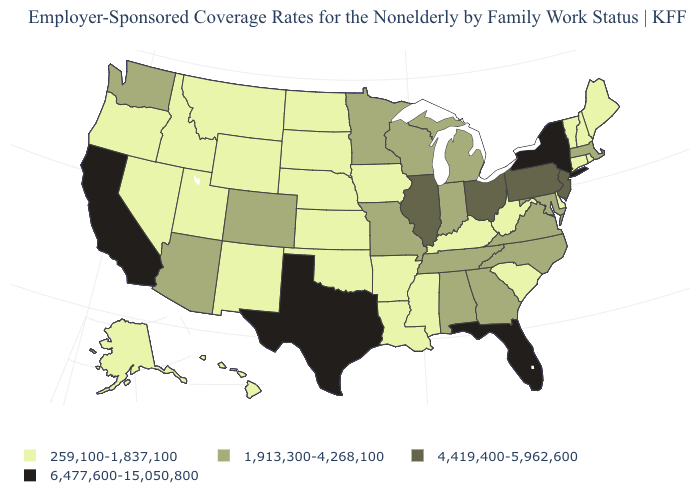Does Ohio have the highest value in the MidWest?
Quick response, please. Yes. What is the value of North Carolina?
Write a very short answer. 1,913,300-4,268,100. What is the value of Iowa?
Be succinct. 259,100-1,837,100. How many symbols are there in the legend?
Be succinct. 4. What is the lowest value in states that border Wisconsin?
Write a very short answer. 259,100-1,837,100. Does Delaware have the highest value in the South?
Answer briefly. No. What is the value of Nebraska?
Be succinct. 259,100-1,837,100. What is the lowest value in states that border Arkansas?
Answer briefly. 259,100-1,837,100. What is the value of Alaska?
Keep it brief. 259,100-1,837,100. Does the first symbol in the legend represent the smallest category?
Answer briefly. Yes. Does the map have missing data?
Give a very brief answer. No. What is the value of Michigan?
Concise answer only. 1,913,300-4,268,100. What is the value of South Carolina?
Give a very brief answer. 259,100-1,837,100. What is the highest value in the USA?
Concise answer only. 6,477,600-15,050,800. Name the states that have a value in the range 259,100-1,837,100?
Concise answer only. Alaska, Arkansas, Connecticut, Delaware, Hawaii, Idaho, Iowa, Kansas, Kentucky, Louisiana, Maine, Mississippi, Montana, Nebraska, Nevada, New Hampshire, New Mexico, North Dakota, Oklahoma, Oregon, Rhode Island, South Carolina, South Dakota, Utah, Vermont, West Virginia, Wyoming. 